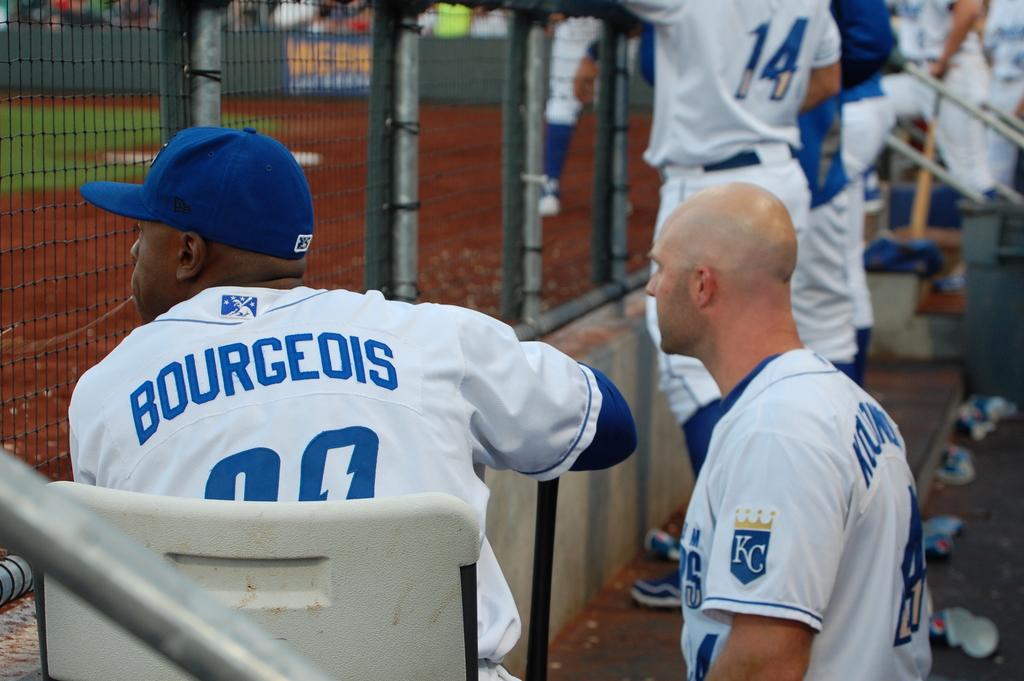What are the team initials in the logo on the sleeve?
Your response must be concise. Kc. Who is that player?
Offer a very short reply. Bourgeois. 